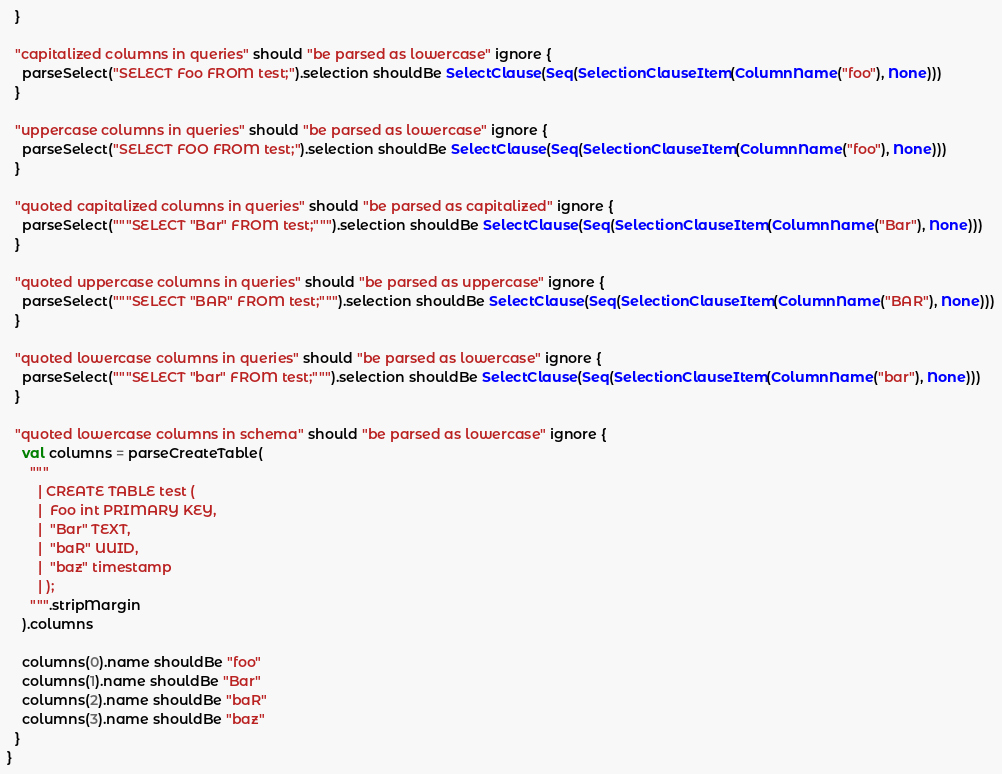Convert code to text. <code><loc_0><loc_0><loc_500><loc_500><_Scala_>  }

  "capitalized columns in queries" should "be parsed as lowercase" ignore {
    parseSelect("SELECT Foo FROM test;").selection shouldBe SelectClause(Seq(SelectionClauseItem(ColumnName("foo"), None)))
  }

  "uppercase columns in queries" should "be parsed as lowercase" ignore {
    parseSelect("SELECT FOO FROM test;").selection shouldBe SelectClause(Seq(SelectionClauseItem(ColumnName("foo"), None)))
  }

  "quoted capitalized columns in queries" should "be parsed as capitalized" ignore {
    parseSelect("""SELECT "Bar" FROM test;""").selection shouldBe SelectClause(Seq(SelectionClauseItem(ColumnName("Bar"), None)))
  }

  "quoted uppercase columns in queries" should "be parsed as uppercase" ignore {
    parseSelect("""SELECT "BAR" FROM test;""").selection shouldBe SelectClause(Seq(SelectionClauseItem(ColumnName("BAR"), None)))
  }

  "quoted lowercase columns in queries" should "be parsed as lowercase" ignore {
    parseSelect("""SELECT "bar" FROM test;""").selection shouldBe SelectClause(Seq(SelectionClauseItem(ColumnName("bar"), None)))
  }

  "quoted lowercase columns in schema" should "be parsed as lowercase" ignore {
    val columns = parseCreateTable(
      """
        | CREATE TABLE test (
        |  Foo int PRIMARY KEY,
        |  "Bar" TEXT,
        |  "baR" UUID,
        |  "baz" timestamp
        | );
      """.stripMargin
    ).columns

    columns(0).name shouldBe "foo"
    columns(1).name shouldBe "Bar"
    columns(2).name shouldBe "baR"
    columns(3).name shouldBe "baz"
  }
}
</code> 